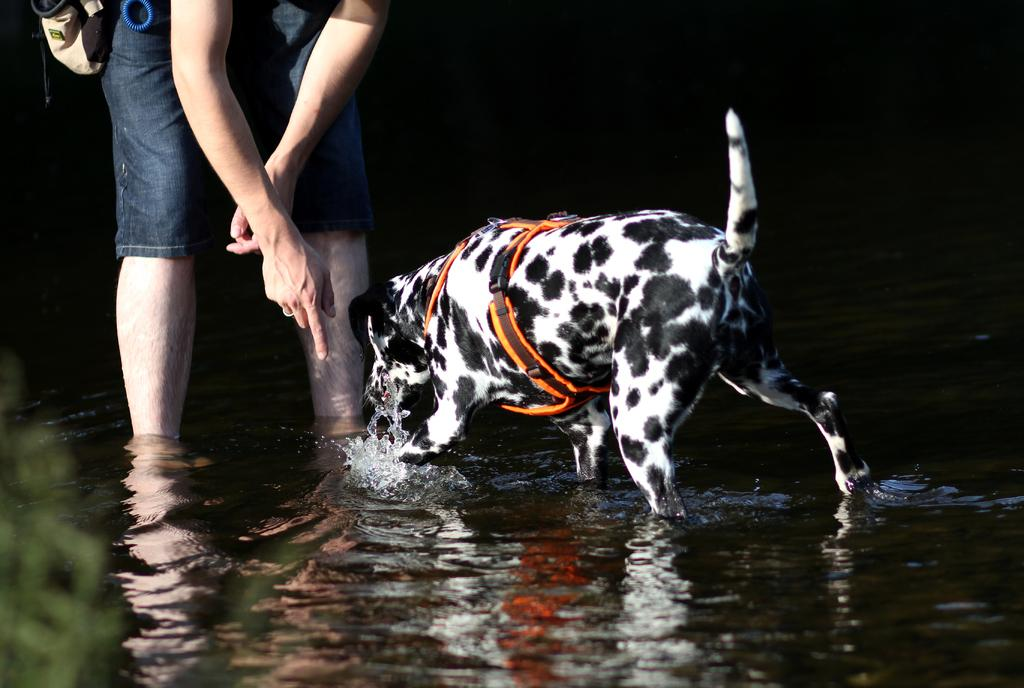What type of animal is in the image? There is a dog in the image. Who is with the dog in the image? There is a man in the image. Where are the man and dog located in the image? The man and dog are standing in the water. What can be seen on the left side of the image? There is a plant on the left side of the image. How would you describe the overall lighting in the image? The backdrop of the image is dark. What type of letters can be seen in the oven in the image? There is no oven or letters present in the image. 